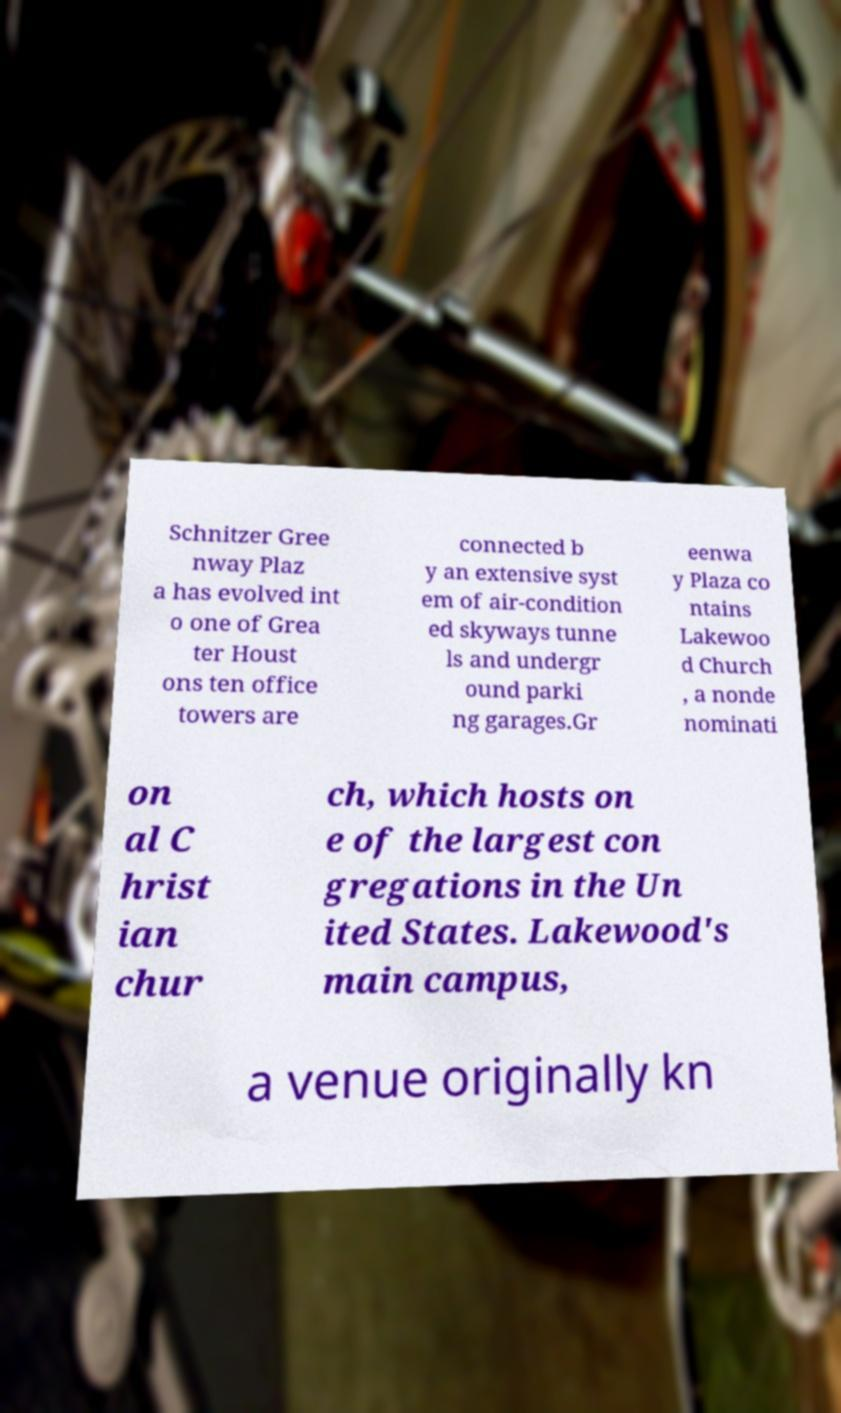There's text embedded in this image that I need extracted. Can you transcribe it verbatim? Schnitzer Gree nway Plaz a has evolved int o one of Grea ter Houst ons ten office towers are connected b y an extensive syst em of air-condition ed skyways tunne ls and undergr ound parki ng garages.Gr eenwa y Plaza co ntains Lakewoo d Church , a nonde nominati on al C hrist ian chur ch, which hosts on e of the largest con gregations in the Un ited States. Lakewood's main campus, a venue originally kn 